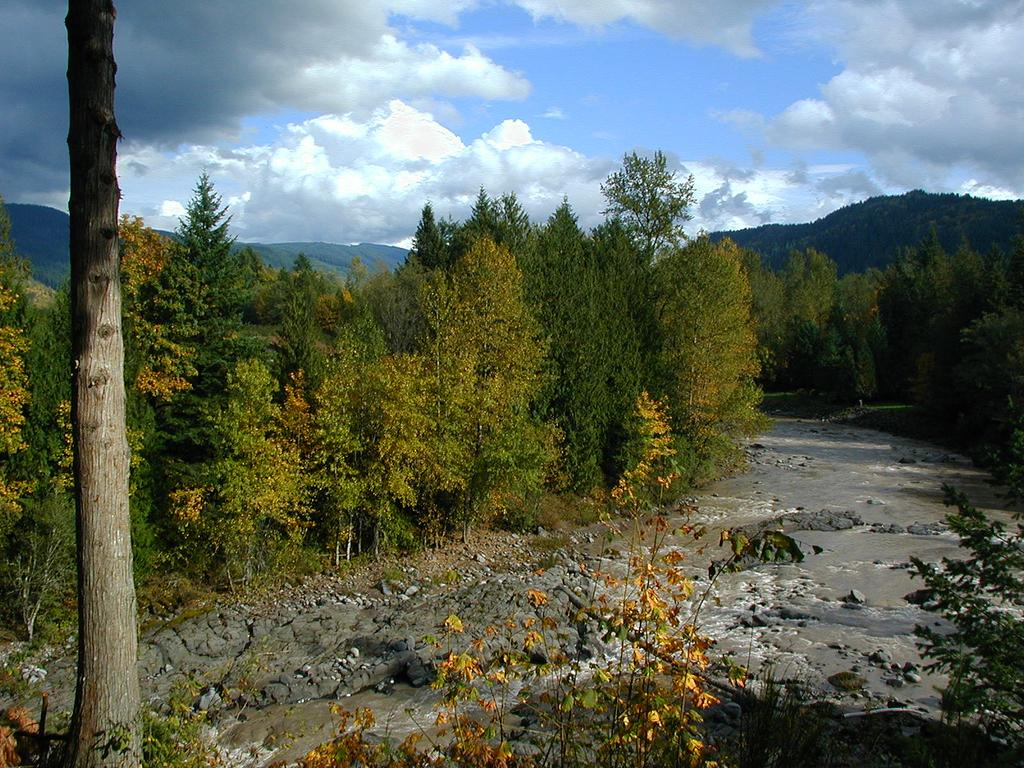What can be found at the bottom of the image? There are stones, trees, and water at the bottom of the image. What is visible in the background of the image? There are mountains, sky, and trees in the background of the image. Can you describe the tree trunk on the left side of the image? There is a tree trunk to the left side of the image. How many balls can be seen rolling down the mountains in the image? There are no balls present in the image, and therefore no such activity can be observed. What type of earthquake is depicted in the image? There is no earthquake depicted in the image; it features a landscape with mountains, trees, and water. 